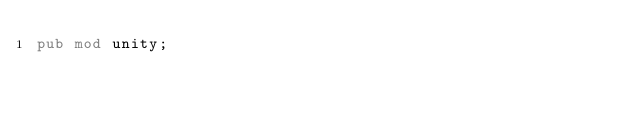<code> <loc_0><loc_0><loc_500><loc_500><_Rust_>pub mod unity;
</code> 